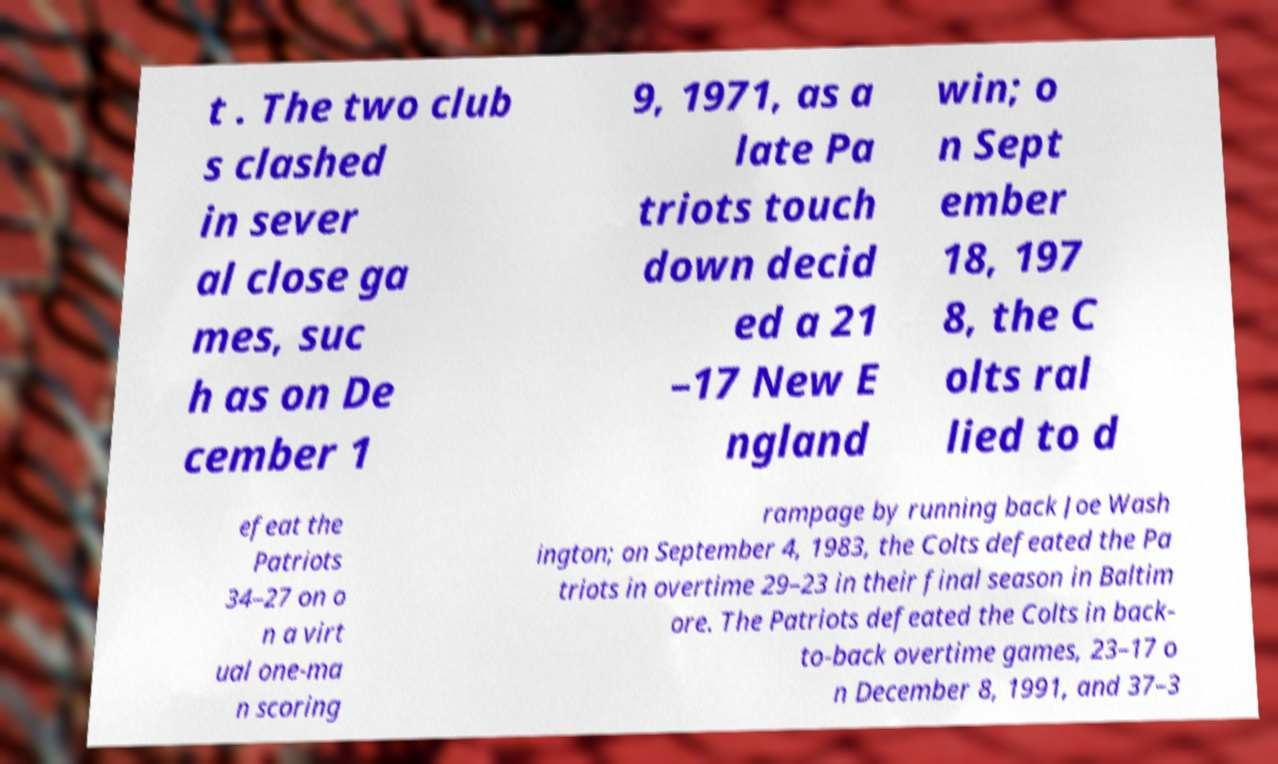Can you accurately transcribe the text from the provided image for me? t . The two club s clashed in sever al close ga mes, suc h as on De cember 1 9, 1971, as a late Pa triots touch down decid ed a 21 –17 New E ngland win; o n Sept ember 18, 197 8, the C olts ral lied to d efeat the Patriots 34–27 on o n a virt ual one-ma n scoring rampage by running back Joe Wash ington; on September 4, 1983, the Colts defeated the Pa triots in overtime 29–23 in their final season in Baltim ore. The Patriots defeated the Colts in back- to-back overtime games, 23–17 o n December 8, 1991, and 37–3 